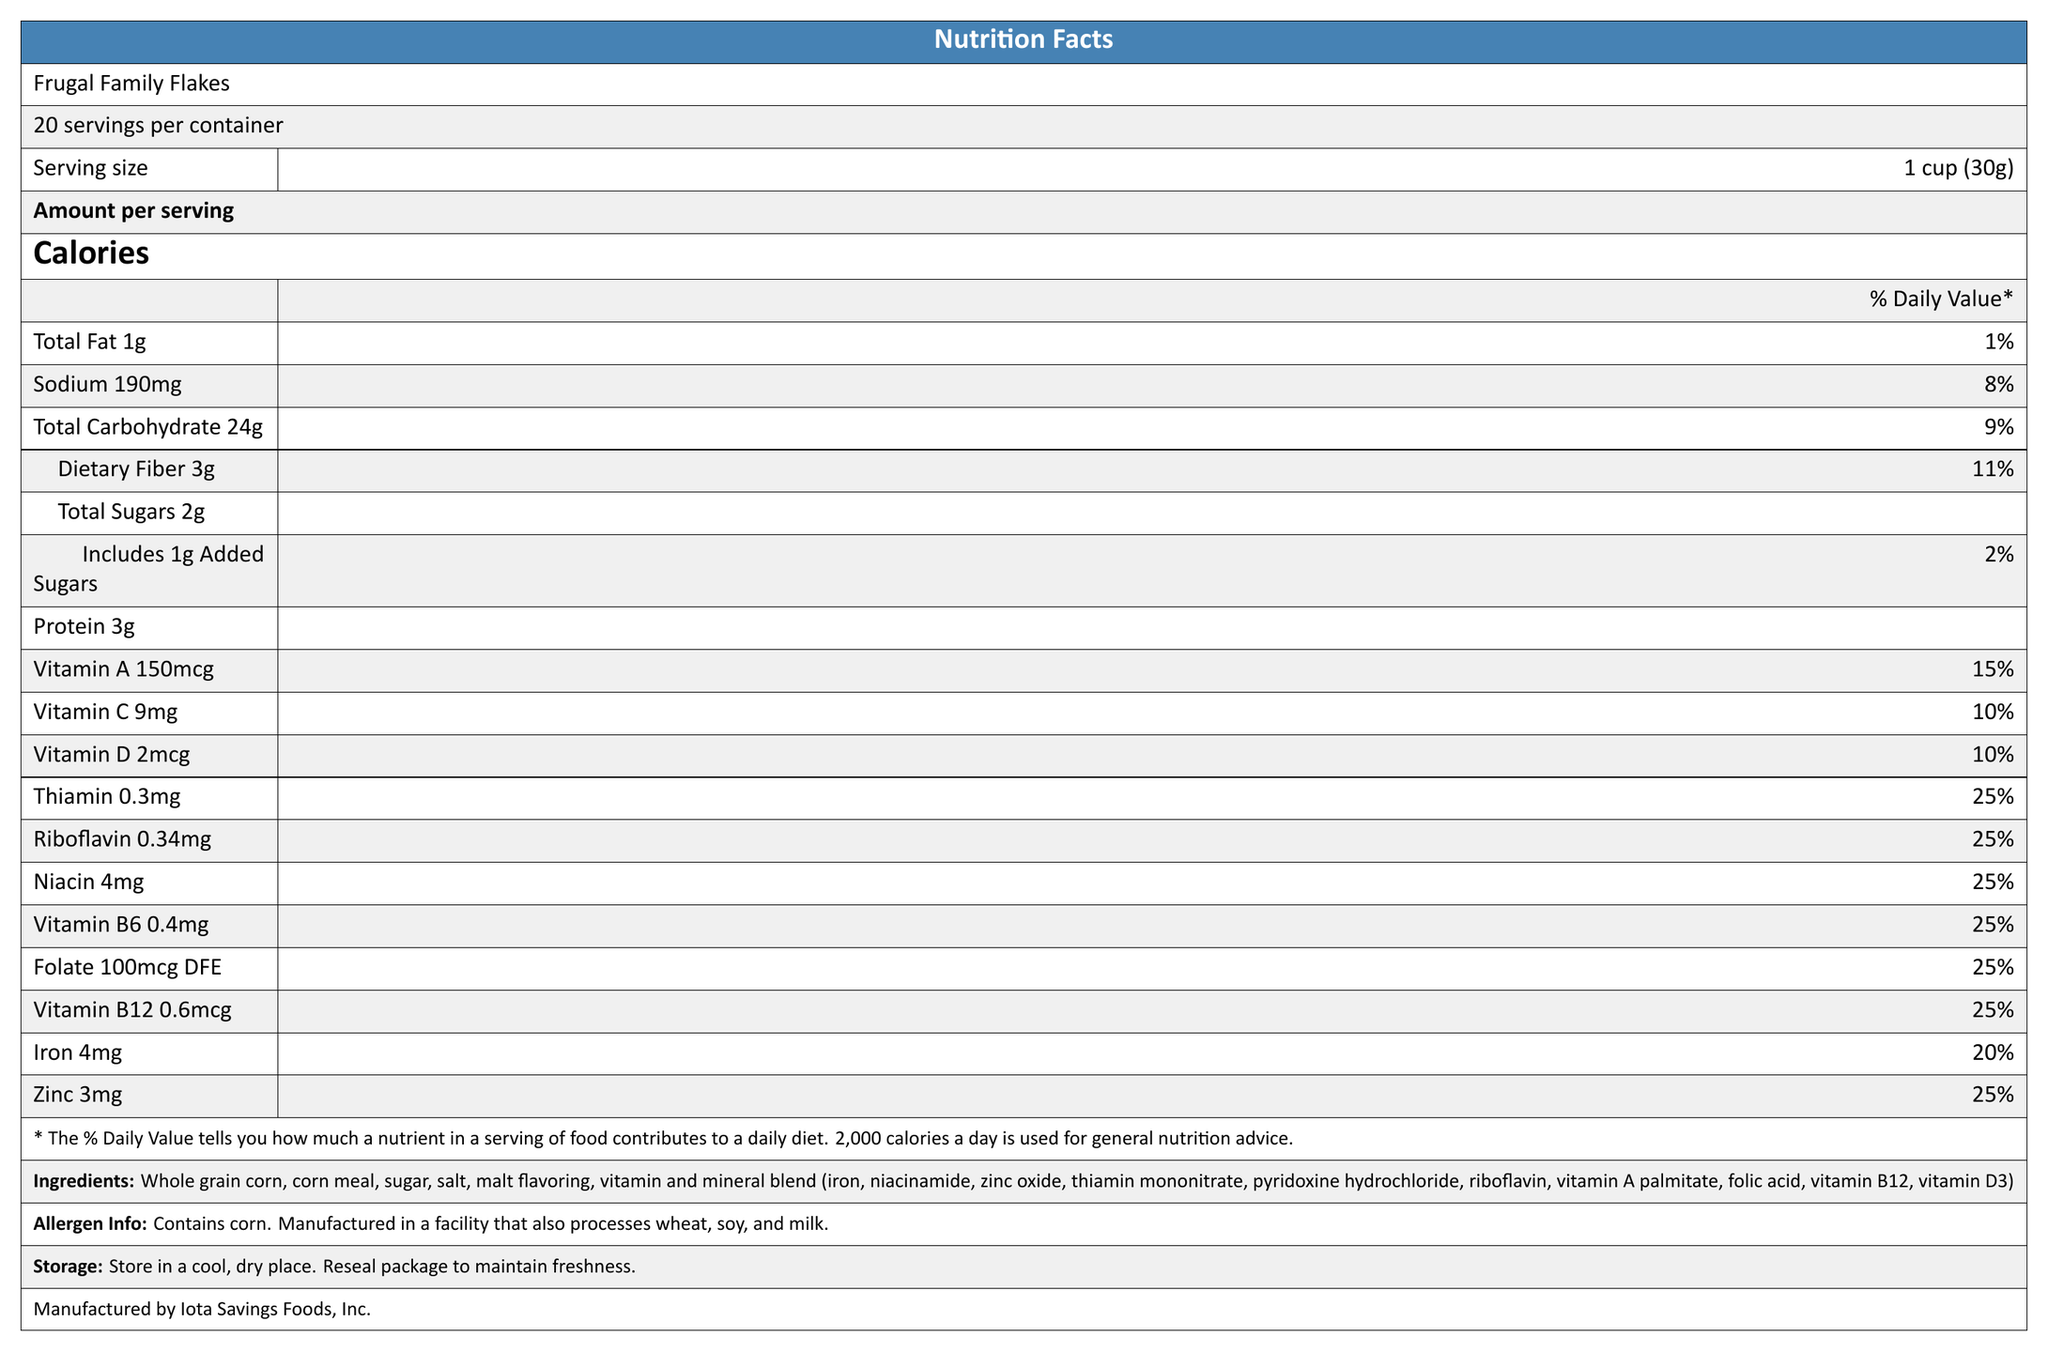what is the serving size? The serving size is clearly listed as "1 cup (30g)" in the document.
Answer: 1 cup (30g) how many calories are in one serving of Frugal Family Flakes? The document states that the amount of calories per serving is 110.
Answer: 110 calories how much dietary fiber is in a serving, and what percent of the daily value does this represent? The document indicates that each serving contains 3 grams of dietary fiber, which is 11% of the daily value.
Answer: 3g, 11% how many grams of added sugars are there per serving? The document specifies that there is 1 gram of added sugars per serving.
Answer: 1g how many servings are in the entire box? The document mentions that there are "about 20" servings per container.
Answer: about 20 what percentage of the daily value of Vitamin B6 is in one serving? The document indicates that a serving contains 25% of the daily value of Vitamin B6.
Answer: 25% what is the amount of iron per serving, and what percentage of the daily value does it provide? The document lists iron content as 4mg per serving, which is 20% of the daily value.
Answer: 4mg, 20% which of the following vitamins is NOT listed in the fortified vitamins and minerals section? A. Vitamin E B. Vitamin A C. Folate D. Vitamin B12 The fortified vitamins and minerals section does not list Vitamin E; Vitamin A, Folate, and Vitamin B12 are listed.
Answer: A. Vitamin E how much sodium is in a serving? The document states that there are 190mg of sodium per serving.
Answer: 190mg how should the product be stored? The document includes storage instructions: "Store in a cool, dry place. Reseal package to maintain freshness."
Answer: In a cool, dry place, reseal package to maintain freshness What is the protein content per serving? A. 2g B. 3g C. 4g D. 5g The document states that each serving contains 3 grams of protein.
Answer: B. 3g does the product contain any allergens? The allergen information states that the product contains corn and is manufactured in a facility that also processes wheat, soy, and milk.
Answer: Yes summarize the document's main idea. The document is a nutrition facts label for Frugal Family Flakes cereal, noting the serving size, calories, and nutrient content, along with information on ingredients, allergens, storage, and manufacturing.
Answer: The document provides the nutrition facts label for a family-size box of Frugal Family Flakes cereal, emphasizing its nutritional content and fortified vitamins and minerals. It also includes storage instructions, allergen information, and manufacturer details. who is the manufacturer of the cereal? The document lists "Manufactured by Iota Savings Foods, Inc."
Answer: Iota Savings Foods, Inc. What is the main ingredient in the cereal? A. Corn meal B. Sugar C. Whole grain corn D. Salt The ingredient list starts with whole grain corn, indicating it is the main ingredient.
Answer: C. Whole grain corn can the amount of dietary fiber per serving be multiplied by the total servings to determine the fiber per container? While you could multiply these numbers, the document indicates "about 20" servings per container, making it an estimate rather than a precise calculation.
Answer: No, not precisely what is the sum of the percent daily values for Thiamin, Riboflavin, and Niacin in each serving? Each serving contains 25% of the daily value for Thiamin, Riboflavin, and Niacin, summing to a total of 75%.
Answer: 75% is Frugal Family Flakes considered a high source of iron based on the % daily value? (Yes/No) A high source usually contributes 20% or more of the daily value, and while 20% is provided, it's right on the threshold and may not be considered "high" without additional context.
Answer: No can a comparison be made between the calorie content and the protein content of the cereal based on the visual information? The visual information allows comparing calories (110 per serving) and protein (3g per serving).
Answer: Yes 